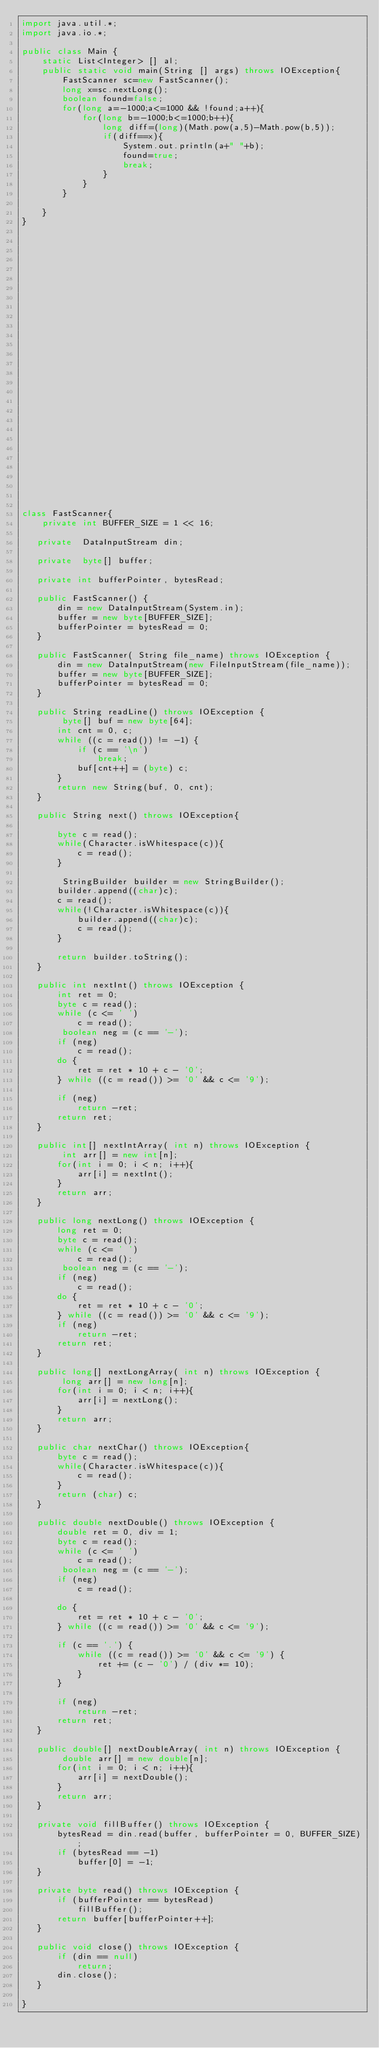Convert code to text. <code><loc_0><loc_0><loc_500><loc_500><_Java_>import java.util.*;
import java.io.*;

public class Main {
    static List<Integer> [] al;
    public static void main(String [] args) throws IOException{
        FastScanner sc=new FastScanner();
        long x=sc.nextLong();
        boolean found=false;
        for(long a=-1000;a<=1000 && !found;a++){
            for(long b=-1000;b<=1000;b++){
                long diff=(long)(Math.pow(a,5)-Math.pow(b,5));
                if(diff==x){
                    System.out.println(a+" "+b);
                    found=true;
                    break;
                }
            }
        }

    }
}






























class FastScanner{	
    private int BUFFER_SIZE = 1 << 16;
   
   private  DataInputStream din;
   
   private  byte[] buffer;
   
   private int bufferPointer, bytesRead;
   
   public FastScanner() {
       din = new DataInputStream(System.in);
       buffer = new byte[BUFFER_SIZE];
       bufferPointer = bytesRead = 0;
   }

   public FastScanner( String file_name) throws IOException {
       din = new DataInputStream(new FileInputStream(file_name));
       buffer = new byte[BUFFER_SIZE];
       bufferPointer = bytesRead = 0;
   }
   
   public String readLine() throws IOException {
        byte[] buf = new byte[64];
       int cnt = 0, c;
       while ((c = read()) != -1) {
           if (c == '\n')
               break;
           buf[cnt++] = (byte) c;
       }
       return new String(buf, 0, cnt);
   }
   
   public String next() throws IOException{

       byte c = read();
       while(Character.isWhitespace(c)){
           c = read();
       }
       
        StringBuilder builder = new StringBuilder();
       builder.append((char)c);
       c = read();
       while(!Character.isWhitespace(c)){
           builder.append((char)c);
           c = read();
       }
       
       return builder.toString();
   }

   public int nextInt() throws IOException {
       int ret = 0;
       byte c = read();
       while (c <= ' ')
           c = read();
        boolean neg = (c == '-');
       if (neg)
           c = read();
       do {
           ret = ret * 10 + c - '0';
       } while ((c = read()) >= '0' && c <= '9');

       if (neg)
           return -ret;
       return ret;
   }
   
   public int[] nextIntArray( int n) throws IOException {
        int arr[] = new int[n];
       for(int i = 0; i < n; i++){
           arr[i] = nextInt();
       }
       return arr;
   }

   public long nextLong() throws IOException {
       long ret = 0;
       byte c = read();
       while (c <= ' ')
           c = read();
        boolean neg = (c == '-');
       if (neg)
           c = read();
       do {
           ret = ret * 10 + c - '0';
       } while ((c = read()) >= '0' && c <= '9');
       if (neg)
           return -ret;
       return ret;
   }
   
   public long[] nextLongArray( int n) throws IOException {
        long arr[] = new long[n];
       for(int i = 0; i < n; i++){
           arr[i] = nextLong();
       }
       return arr;
   }

   public char nextChar() throws IOException{
       byte c = read();
       while(Character.isWhitespace(c)){
           c = read();
       }
       return (char) c;	
   }
   
   public double nextDouble() throws IOException {
       double ret = 0, div = 1;
       byte c = read();
       while (c <= ' ')
           c = read();
        boolean neg = (c == '-');
       if (neg)
           c = read();

       do {
           ret = ret * 10 + c - '0';
       } while ((c = read()) >= '0' && c <= '9');

       if (c == '.') {
           while ((c = read()) >= '0' && c <= '9') {
               ret += (c - '0') / (div *= 10);
           }
       }

       if (neg)
           return -ret;
       return ret;
   }
   
   public double[] nextDoubleArray( int n) throws IOException {
        double arr[] = new double[n];
       for(int i = 0; i < n; i++){
           arr[i] = nextDouble();
       }
       return arr;
   }

   private void fillBuffer() throws IOException {
       bytesRead = din.read(buffer, bufferPointer = 0, BUFFER_SIZE);
       if (bytesRead == -1)
           buffer[0] = -1;
   }

   private byte read() throws IOException {
       if (bufferPointer == bytesRead)
           fillBuffer();
       return buffer[bufferPointer++];
   }

   public void close() throws IOException {
       if (din == null)
           return;
       din.close();
   }

}

</code> 